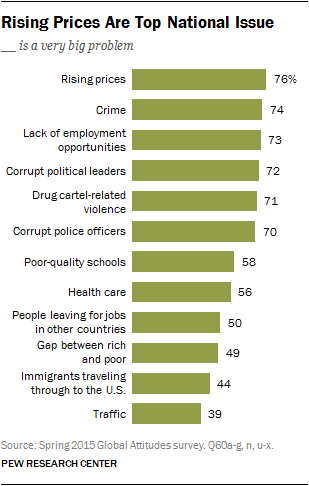Mention a couple of crucial points in this snapshot. Eighty percent of respondents who chose a specific issue as a very big problem had over 50 respondents selecting it as a big problem. There are 12 issues presented in the graph. 